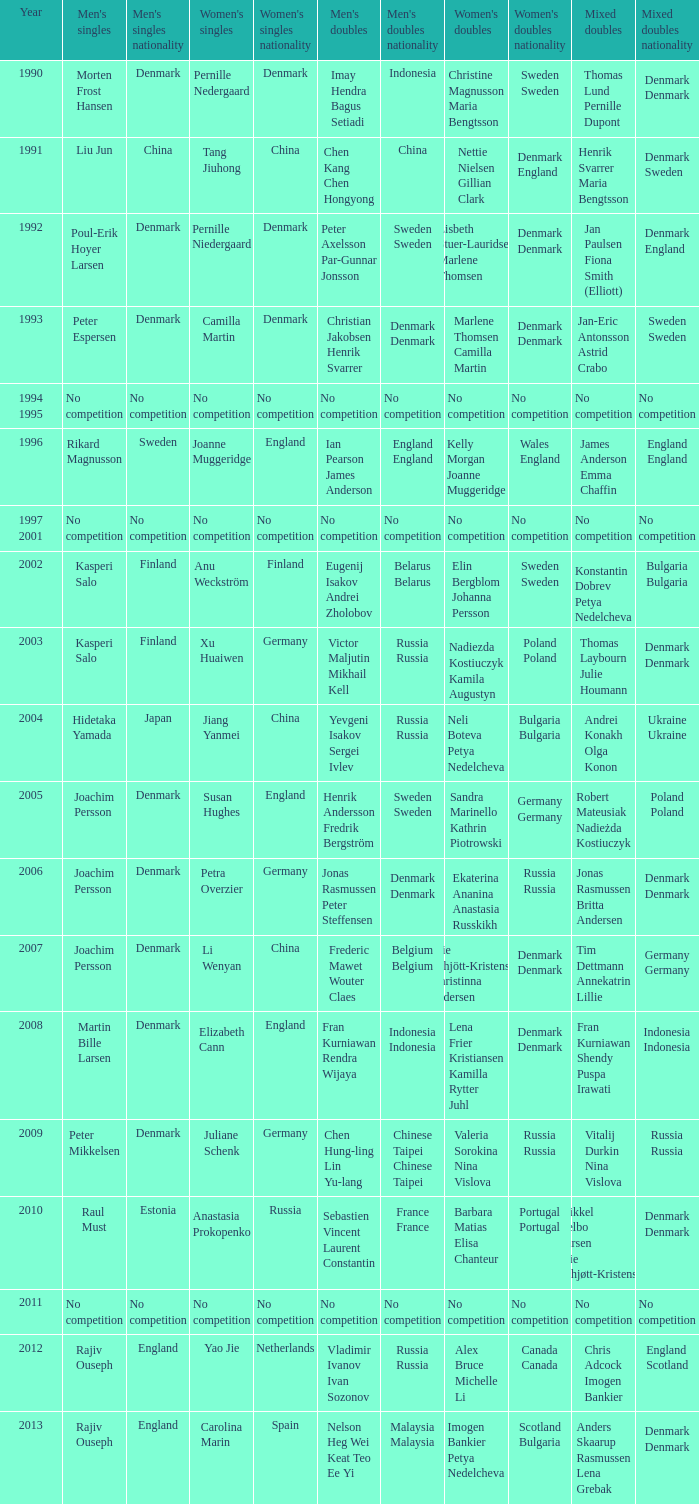Who won the Mixed Doubles in 2007? Tim Dettmann Annekatrin Lillie. 